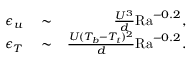<formula> <loc_0><loc_0><loc_500><loc_500>\begin{array} { r l r } { \epsilon _ { u } } & \sim } & { \frac { U ^ { 3 } } { d } R a ^ { - 0 . 2 } , } \\ { \epsilon _ { T } } & \sim } & { \frac { U ( T _ { b } - T _ { t } ) ^ { 2 } } { d } R a ^ { - 0 . 2 } . } \end{array}</formula> 